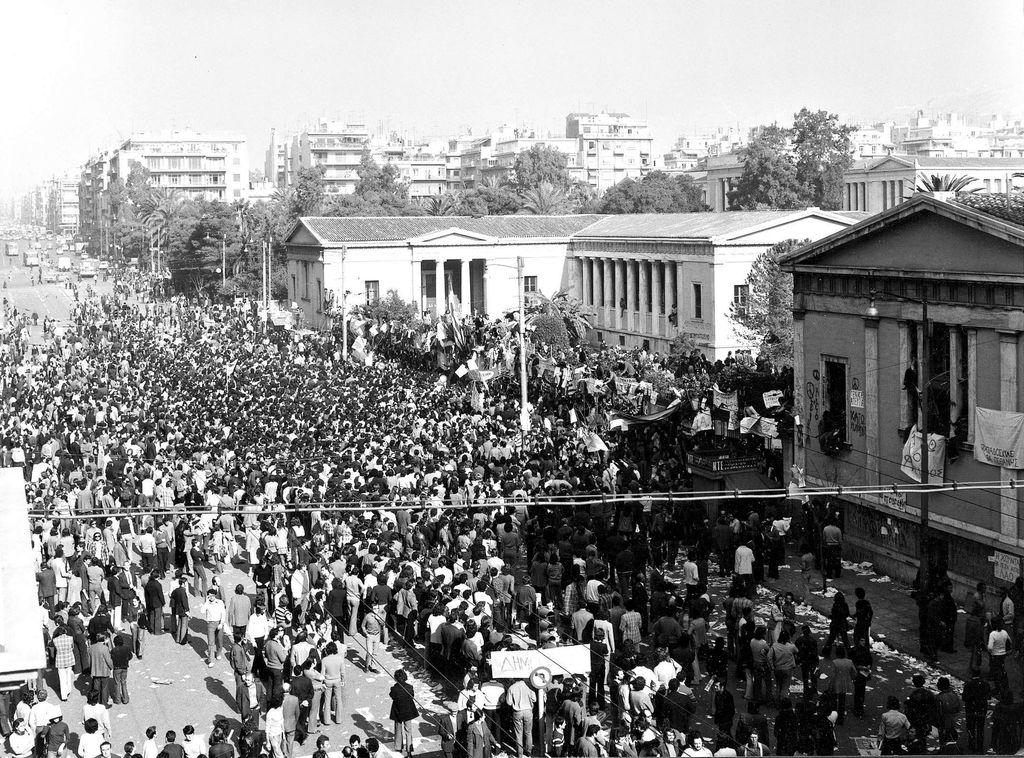What is the color scheme of the image? The image is black and white. What can be seen happening at the bottom of the image? There is a crowd of people walking on the road at the bottom of the image. What is visible in the background of the image? There are many buildings and trees in the background of the image. What is visible at the top of the image? The sky is visible at the top of the image. What type of stone is being used as a title for the image? There is no stone or title present in the image; it is a black and white image of a crowd of people walking on the road with buildings, trees, and sky in the background. Can you tell me how many rats are visible in the image? There are no rats present in the image. 